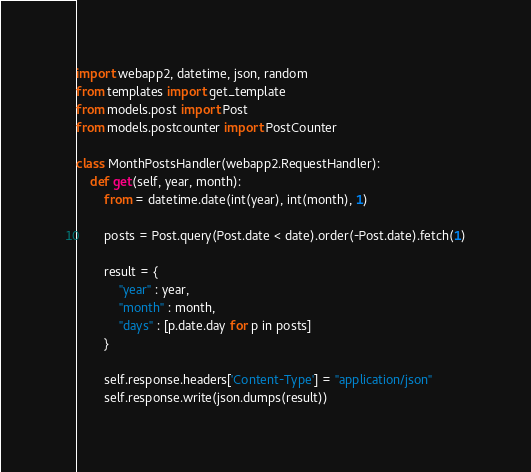Convert code to text. <code><loc_0><loc_0><loc_500><loc_500><_Python_>import webapp2, datetime, json, random
from templates import get_template
from models.post import Post
from models.postcounter import PostCounter

class MonthPostsHandler(webapp2.RequestHandler):
	def get(self, year, month):
		from = datetime.date(int(year), int(month), 1)

		posts = Post.query(Post.date < date).order(-Post.date).fetch(1)

		result = {
			"year" : year,
			"month" : month,
			"days" : [p.date.day for p in posts]
		}

		self.response.headers['Content-Type'] = "application/json"
		self.response.write(json.dumps(result))


</code> 